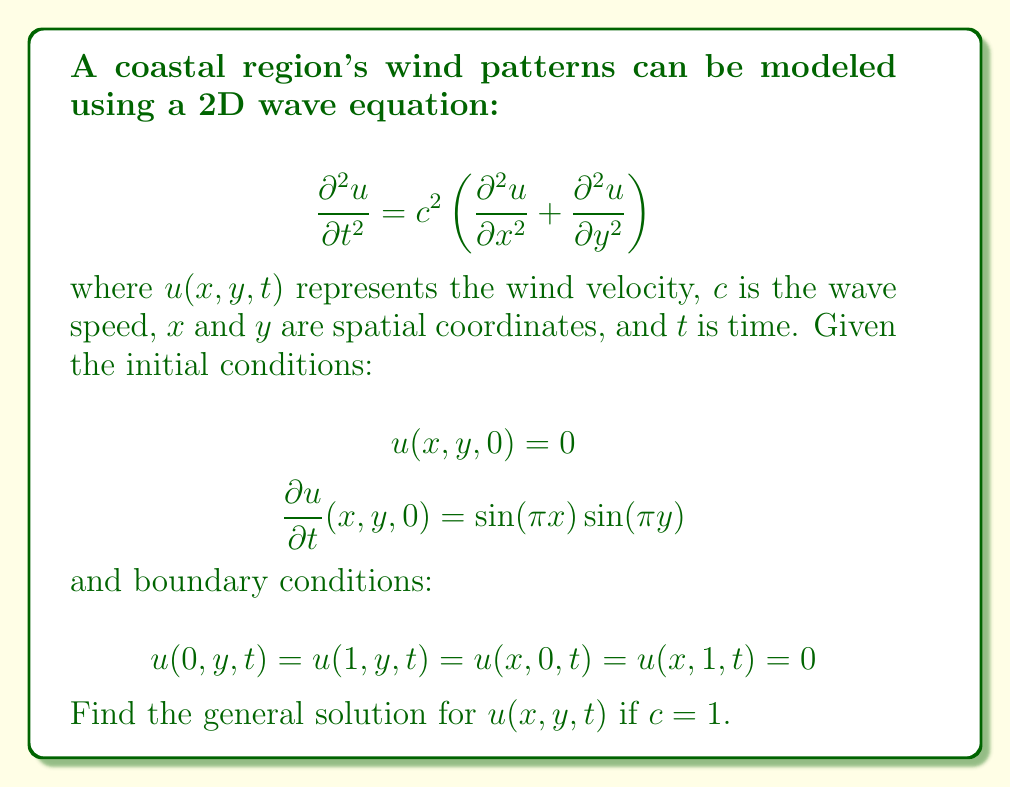What is the answer to this math problem? To solve this 2D wave equation, we'll use the method of separation of variables:

1) Assume a solution of the form: $u(x,y,t) = X(x)Y(y)T(t)$

2) Substitute this into the wave equation:
   $$XYT'' = c^2(X''YT + XY''T)$$

3) Divide by $XYT$:
   $$\frac{T''}{T} = c^2\left(\frac{X''}{X} + \frac{Y''}{Y}\right)$$

4) Since the left side depends only on $t$ and the right side only on $x$ and $y$, both must equal a constant. Let's call it $-\lambda$:
   $$\frac{T''}{T} = -\lambda = c^2\left(\frac{X''}{X} + \frac{Y''}{Y}\right)$$

5) This gives us three ODEs:
   $$T'' + \lambda T = 0$$
   $$X'' + \mu X = 0$$
   $$Y'' + \nu Y = 0$$
   where $\lambda = c^2(\mu + \nu)$

6) The boundary conditions suggest:
   $X(0) = X(1) = 0$ and $Y(0) = Y(1) = 0$

7) These lead to the solutions:
   $$X(x) = \sin(m\pi x), m = 1,2,3,...$$
   $$Y(y) = \sin(n\pi y), n = 1,2,3,...$$
   where $\mu = m^2\pi^2$ and $\nu = n^2\pi^2$

8) For $T(t)$, we have:
   $$T(t) = A\cos(\omega t) + B\sin(\omega t)$$
   where $\omega = c\sqrt{\lambda} = c\pi\sqrt{m^2 + n^2}$

9) The general solution is:
   $$u(x,y,t) = \sum_{m=1}^{\infty}\sum_{n=1}^{\infty} [A_{mn}\cos(c\pi\sqrt{m^2+n^2}t) + B_{mn}\sin(c\pi\sqrt{m^2+n^2}t)]\sin(m\pi x)\sin(n\pi y)$$

10) Apply the initial conditions:
    $u(x,y,0) = 0$ implies $A_{mn} = 0$ for all $m,n$
    $\frac{\partial u}{\partial t}(x,y,0) = \sin(\pi x)\sin(\pi y)$ implies $B_{11} = \frac{1}{c\pi\sqrt{2}}$ and $B_{mn} = 0$ for all other $m,n$

11) Substituting $c = 1$, the final solution is:
    $$u(x,y,t) = \frac{1}{\pi\sqrt{2}}\sin(\pi\sqrt{2}t)\sin(\pi x)\sin(\pi y)$$
Answer: $u(x,y,t) = \frac{1}{\pi\sqrt{2}}\sin(\pi\sqrt{2}t)\sin(\pi x)\sin(\pi y)$ 